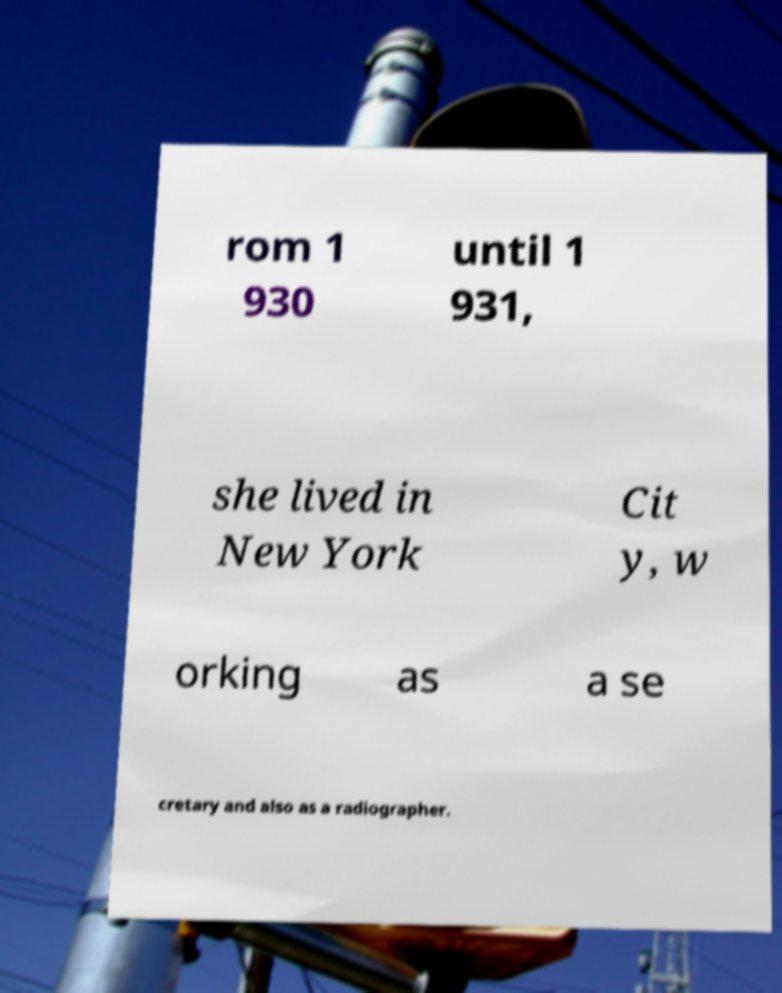I need the written content from this picture converted into text. Can you do that? rom 1 930 until 1 931, she lived in New York Cit y, w orking as a se cretary and also as a radiographer. 